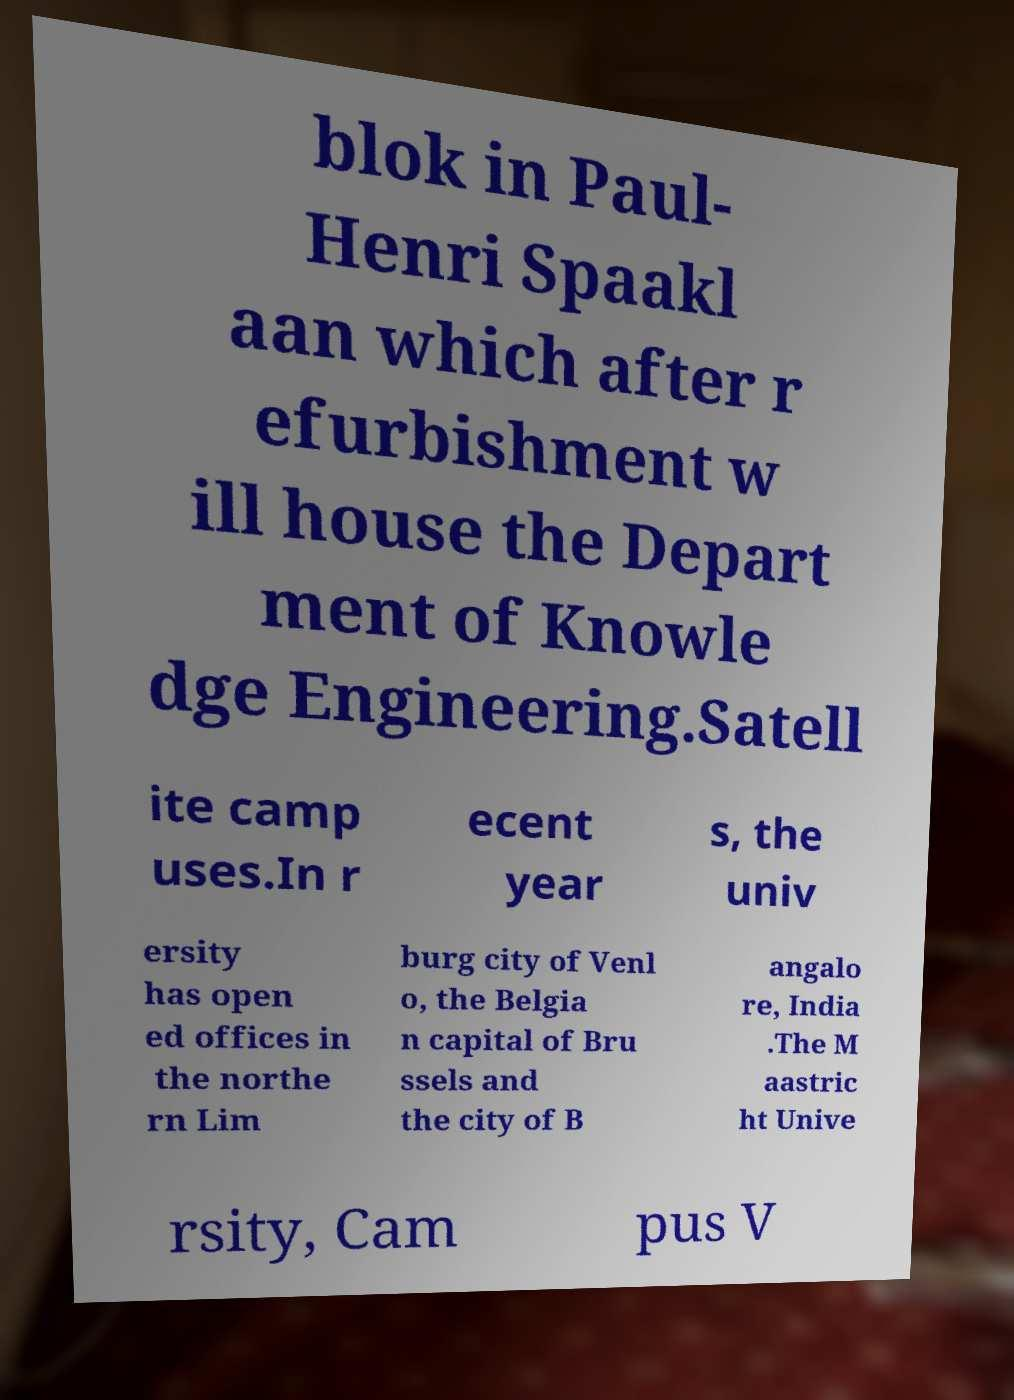Could you extract and type out the text from this image? blok in Paul- Henri Spaakl aan which after r efurbishment w ill house the Depart ment of Knowle dge Engineering.Satell ite camp uses.In r ecent year s, the univ ersity has open ed offices in the northe rn Lim burg city of Venl o, the Belgia n capital of Bru ssels and the city of B angalo re, India .The M aastric ht Unive rsity, Cam pus V 